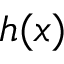<formula> <loc_0><loc_0><loc_500><loc_500>h ( x )</formula> 